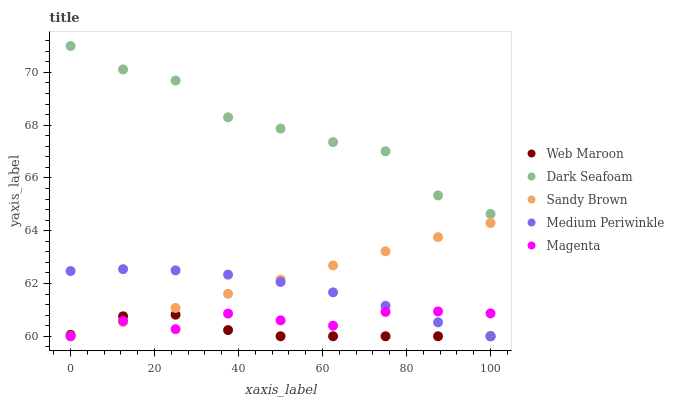Does Web Maroon have the minimum area under the curve?
Answer yes or no. Yes. Does Dark Seafoam have the maximum area under the curve?
Answer yes or no. Yes. Does Dark Seafoam have the minimum area under the curve?
Answer yes or no. No. Does Web Maroon have the maximum area under the curve?
Answer yes or no. No. Is Sandy Brown the smoothest?
Answer yes or no. Yes. Is Dark Seafoam the roughest?
Answer yes or no. Yes. Is Web Maroon the smoothest?
Answer yes or no. No. Is Web Maroon the roughest?
Answer yes or no. No. Does Sandy Brown have the lowest value?
Answer yes or no. Yes. Does Dark Seafoam have the lowest value?
Answer yes or no. No. Does Dark Seafoam have the highest value?
Answer yes or no. Yes. Does Web Maroon have the highest value?
Answer yes or no. No. Is Medium Periwinkle less than Dark Seafoam?
Answer yes or no. Yes. Is Dark Seafoam greater than Web Maroon?
Answer yes or no. Yes. Does Web Maroon intersect Medium Periwinkle?
Answer yes or no. Yes. Is Web Maroon less than Medium Periwinkle?
Answer yes or no. No. Is Web Maroon greater than Medium Periwinkle?
Answer yes or no. No. Does Medium Periwinkle intersect Dark Seafoam?
Answer yes or no. No. 